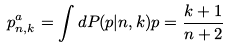Convert formula to latex. <formula><loc_0><loc_0><loc_500><loc_500>p ^ { a } _ { n , k } = \int d P ( p | n , k ) p = \frac { k + 1 } { n + 2 }</formula> 